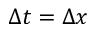<formula> <loc_0><loc_0><loc_500><loc_500>\Delta t = \Delta x</formula> 